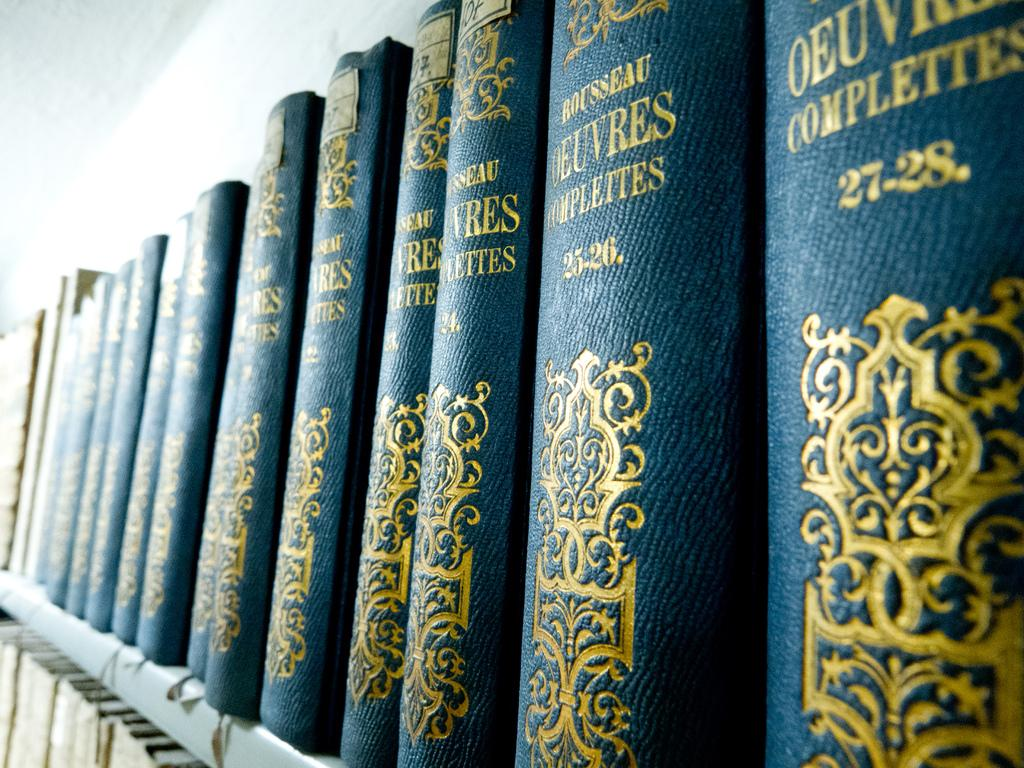<image>
Present a compact description of the photo's key features. Books by Rousseau feature blue and gold bindings. 